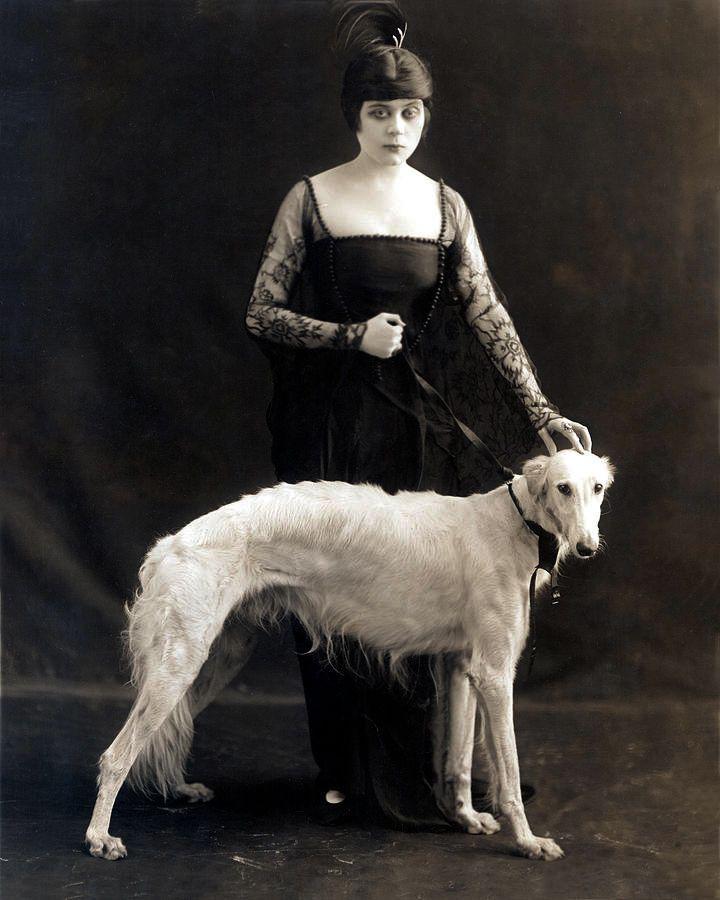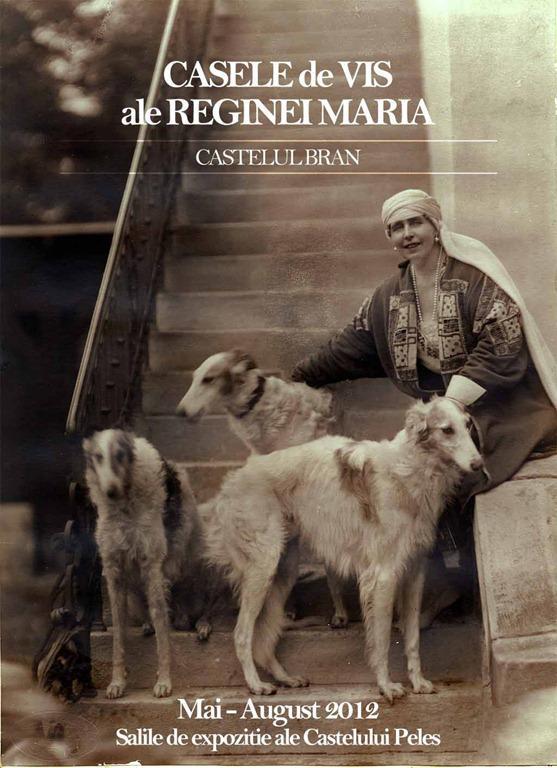The first image is the image on the left, the second image is the image on the right. Considering the images on both sides, is "In one image, a woman wearing a long dark dress with long sleeves is posed for a studio portrait with her hand on the head of a large white dog." valid? Answer yes or no. Yes. The first image is the image on the left, the second image is the image on the right. Considering the images on both sides, is "The left image shows a woman in black standing behind one white hound." valid? Answer yes or no. Yes. 